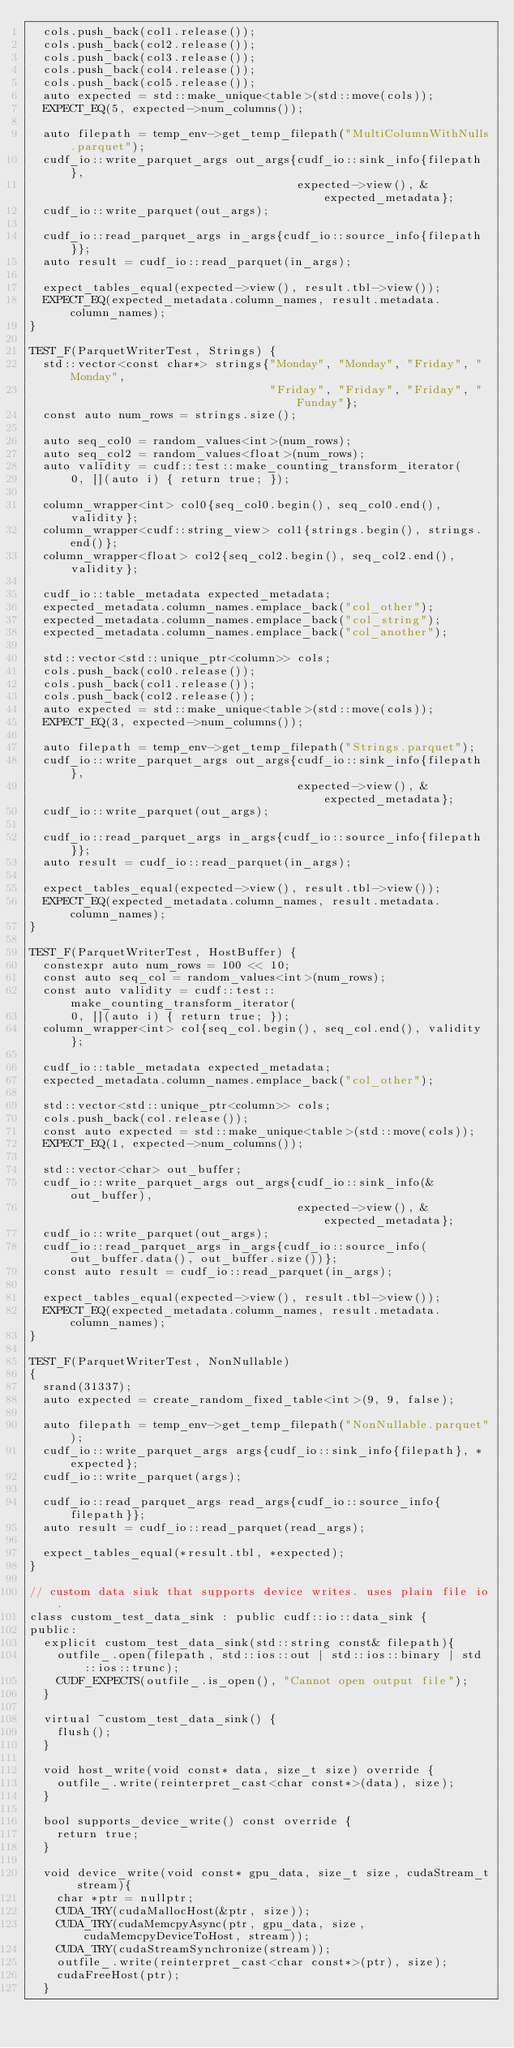Convert code to text. <code><loc_0><loc_0><loc_500><loc_500><_Cuda_>  cols.push_back(col1.release());
  cols.push_back(col2.release());
  cols.push_back(col3.release());
  cols.push_back(col4.release());
  cols.push_back(col5.release());
  auto expected = std::make_unique<table>(std::move(cols));
  EXPECT_EQ(5, expected->num_columns());

  auto filepath = temp_env->get_temp_filepath("MultiColumnWithNulls.parquet");
  cudf_io::write_parquet_args out_args{cudf_io::sink_info{filepath},
                                       expected->view(), &expected_metadata};
  cudf_io::write_parquet(out_args);

  cudf_io::read_parquet_args in_args{cudf_io::source_info{filepath}};
  auto result = cudf_io::read_parquet(in_args);

  expect_tables_equal(expected->view(), result.tbl->view());
  EXPECT_EQ(expected_metadata.column_names, result.metadata.column_names);
}

TEST_F(ParquetWriterTest, Strings) {
  std::vector<const char*> strings{"Monday", "Monday", "Friday", "Monday",
                                   "Friday", "Friday", "Friday", "Funday"};
  const auto num_rows = strings.size();

  auto seq_col0 = random_values<int>(num_rows);
  auto seq_col2 = random_values<float>(num_rows);
  auto validity = cudf::test::make_counting_transform_iterator(
      0, [](auto i) { return true; });

  column_wrapper<int> col0{seq_col0.begin(), seq_col0.end(), validity};
  column_wrapper<cudf::string_view> col1{strings.begin(), strings.end()};
  column_wrapper<float> col2{seq_col2.begin(), seq_col2.end(), validity};

  cudf_io::table_metadata expected_metadata;
  expected_metadata.column_names.emplace_back("col_other");
  expected_metadata.column_names.emplace_back("col_string");
  expected_metadata.column_names.emplace_back("col_another");

  std::vector<std::unique_ptr<column>> cols;
  cols.push_back(col0.release());
  cols.push_back(col1.release());
  cols.push_back(col2.release());
  auto expected = std::make_unique<table>(std::move(cols));
  EXPECT_EQ(3, expected->num_columns());

  auto filepath = temp_env->get_temp_filepath("Strings.parquet");
  cudf_io::write_parquet_args out_args{cudf_io::sink_info{filepath},
                                       expected->view(), &expected_metadata};
  cudf_io::write_parquet(out_args);

  cudf_io::read_parquet_args in_args{cudf_io::source_info{filepath}};
  auto result = cudf_io::read_parquet(in_args);

  expect_tables_equal(expected->view(), result.tbl->view());
  EXPECT_EQ(expected_metadata.column_names, result.metadata.column_names);
}

TEST_F(ParquetWriterTest, HostBuffer) {
  constexpr auto num_rows = 100 << 10;
  const auto seq_col = random_values<int>(num_rows);
  const auto validity = cudf::test::make_counting_transform_iterator(
      0, [](auto i) { return true; });
  column_wrapper<int> col{seq_col.begin(), seq_col.end(), validity};

  cudf_io::table_metadata expected_metadata;
  expected_metadata.column_names.emplace_back("col_other");

  std::vector<std::unique_ptr<column>> cols;
  cols.push_back(col.release());
  const auto expected = std::make_unique<table>(std::move(cols));
  EXPECT_EQ(1, expected->num_columns());

  std::vector<char> out_buffer;
  cudf_io::write_parquet_args out_args{cudf_io::sink_info(&out_buffer),
                                       expected->view(), &expected_metadata};
  cudf_io::write_parquet(out_args);
  cudf_io::read_parquet_args in_args{cudf_io::source_info(out_buffer.data(), out_buffer.size())};
  const auto result = cudf_io::read_parquet(in_args);

  expect_tables_equal(expected->view(), result.tbl->view());
  EXPECT_EQ(expected_metadata.column_names, result.metadata.column_names);
}

TEST_F(ParquetWriterTest, NonNullable)
{
  srand(31337);
  auto expected = create_random_fixed_table<int>(9, 9, false);

  auto filepath = temp_env->get_temp_filepath("NonNullable.parquet");
  cudf_io::write_parquet_args args{cudf_io::sink_info{filepath}, *expected};
  cudf_io::write_parquet(args);

  cudf_io::read_parquet_args read_args{cudf_io::source_info{filepath}};
  auto result = cudf_io::read_parquet(read_args);

  expect_tables_equal(*result.tbl, *expected);
}

// custom data sink that supports device writes. uses plain file io.
class custom_test_data_sink : public cudf::io::data_sink {
public:
  explicit custom_test_data_sink(std::string const& filepath){
    outfile_.open(filepath, std::ios::out | std::ios::binary | std::ios::trunc);
    CUDF_EXPECTS(outfile_.is_open(), "Cannot open output file");
  }

  virtual ~custom_test_data_sink() {
    flush();
  }

  void host_write(void const* data, size_t size) override {
    outfile_.write(reinterpret_cast<char const*>(data), size);
  }

  bool supports_device_write() const override {
    return true;
  }

  void device_write(void const* gpu_data, size_t size, cudaStream_t stream){
    char *ptr = nullptr;
    CUDA_TRY(cudaMallocHost(&ptr, size));
    CUDA_TRY(cudaMemcpyAsync(ptr, gpu_data, size, cudaMemcpyDeviceToHost, stream));
    CUDA_TRY(cudaStreamSynchronize(stream));
    outfile_.write(reinterpret_cast<char const*>(ptr), size);
    cudaFreeHost(ptr);
  }
</code> 